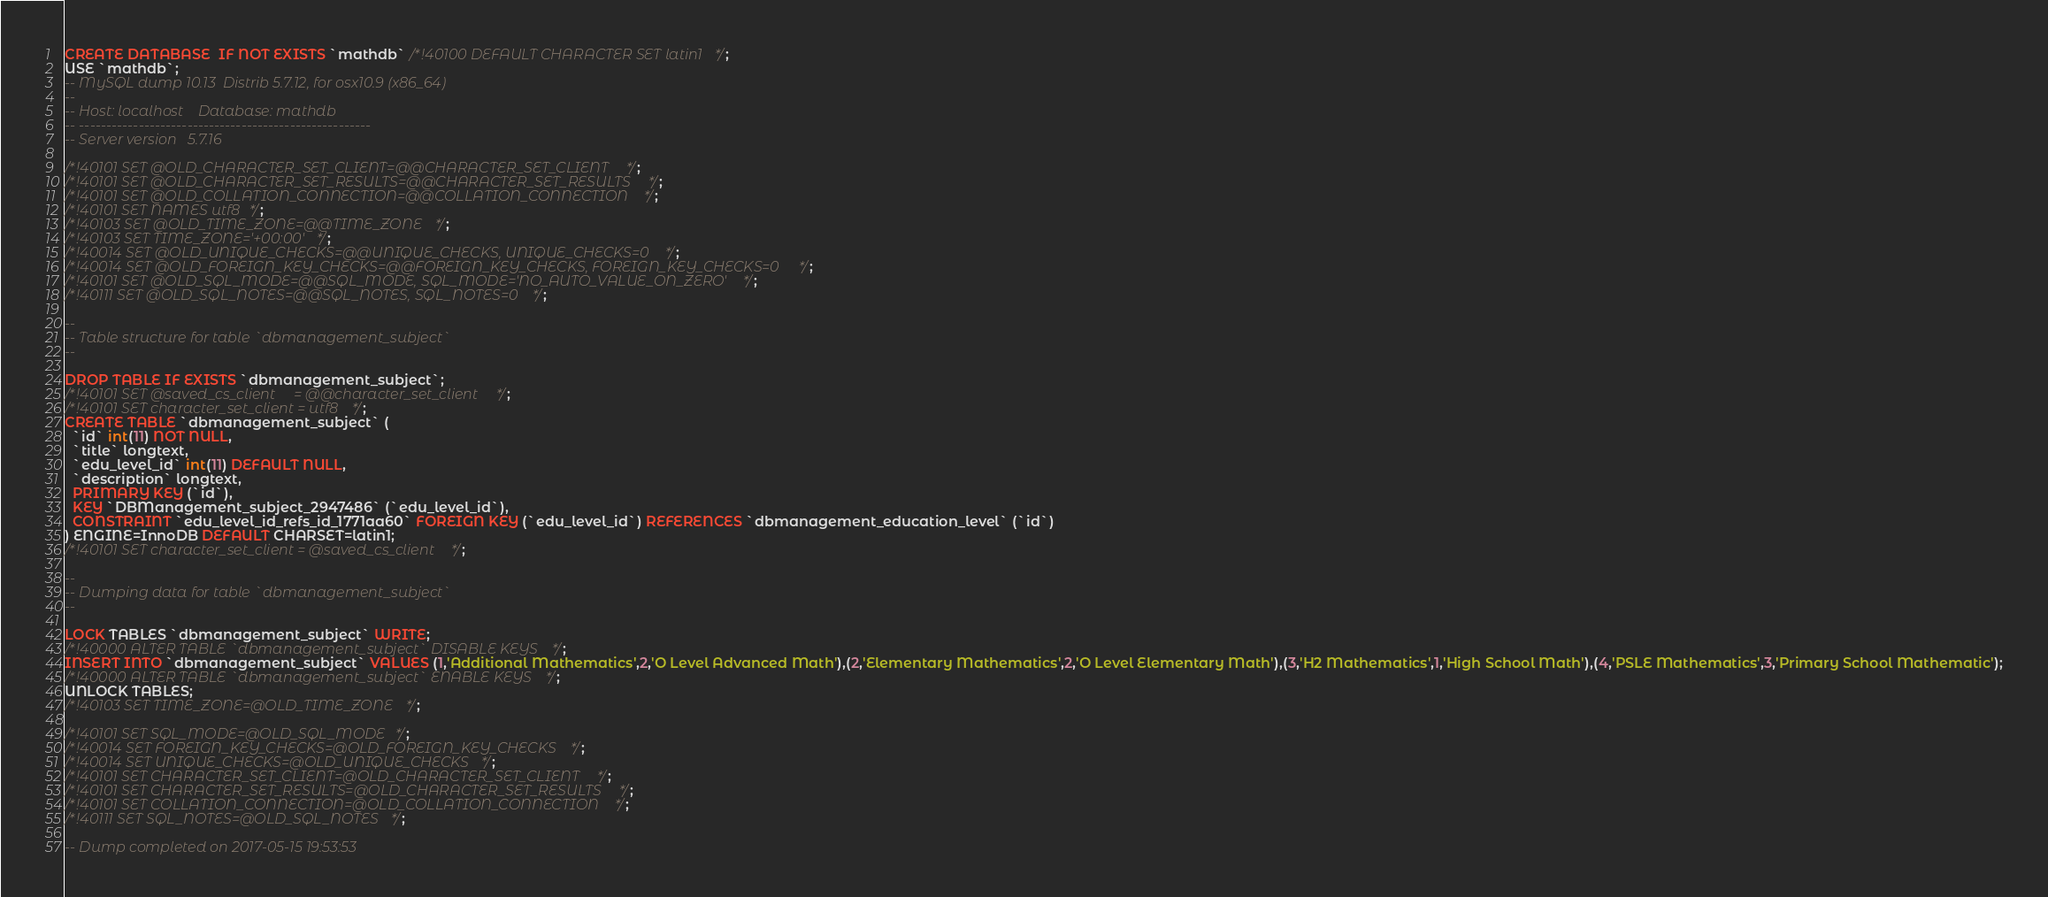Convert code to text. <code><loc_0><loc_0><loc_500><loc_500><_SQL_>CREATE DATABASE  IF NOT EXISTS `mathdb` /*!40100 DEFAULT CHARACTER SET latin1 */;
USE `mathdb`;
-- MySQL dump 10.13  Distrib 5.7.12, for osx10.9 (x86_64)
--
-- Host: localhost    Database: mathdb
-- ------------------------------------------------------
-- Server version	5.7.16

/*!40101 SET @OLD_CHARACTER_SET_CLIENT=@@CHARACTER_SET_CLIENT */;
/*!40101 SET @OLD_CHARACTER_SET_RESULTS=@@CHARACTER_SET_RESULTS */;
/*!40101 SET @OLD_COLLATION_CONNECTION=@@COLLATION_CONNECTION */;
/*!40101 SET NAMES utf8 */;
/*!40103 SET @OLD_TIME_ZONE=@@TIME_ZONE */;
/*!40103 SET TIME_ZONE='+00:00' */;
/*!40014 SET @OLD_UNIQUE_CHECKS=@@UNIQUE_CHECKS, UNIQUE_CHECKS=0 */;
/*!40014 SET @OLD_FOREIGN_KEY_CHECKS=@@FOREIGN_KEY_CHECKS, FOREIGN_KEY_CHECKS=0 */;
/*!40101 SET @OLD_SQL_MODE=@@SQL_MODE, SQL_MODE='NO_AUTO_VALUE_ON_ZERO' */;
/*!40111 SET @OLD_SQL_NOTES=@@SQL_NOTES, SQL_NOTES=0 */;

--
-- Table structure for table `dbmanagement_subject`
--

DROP TABLE IF EXISTS `dbmanagement_subject`;
/*!40101 SET @saved_cs_client     = @@character_set_client */;
/*!40101 SET character_set_client = utf8 */;
CREATE TABLE `dbmanagement_subject` (
  `id` int(11) NOT NULL,
  `title` longtext,
  `edu_level_id` int(11) DEFAULT NULL,
  `description` longtext,
  PRIMARY KEY (`id`),
  KEY `DBManagement_subject_2947486` (`edu_level_id`),
  CONSTRAINT `edu_level_id_refs_id_1771aa60` FOREIGN KEY (`edu_level_id`) REFERENCES `dbmanagement_education_level` (`id`)
) ENGINE=InnoDB DEFAULT CHARSET=latin1;
/*!40101 SET character_set_client = @saved_cs_client */;

--
-- Dumping data for table `dbmanagement_subject`
--

LOCK TABLES `dbmanagement_subject` WRITE;
/*!40000 ALTER TABLE `dbmanagement_subject` DISABLE KEYS */;
INSERT INTO `dbmanagement_subject` VALUES (1,'Additional Mathematics',2,'O Level Advanced Math'),(2,'Elementary Mathematics',2,'O Level Elementary Math'),(3,'H2 Mathematics',1,'High School Math'),(4,'PSLE Mathematics',3,'Primary School Mathematic');
/*!40000 ALTER TABLE `dbmanagement_subject` ENABLE KEYS */;
UNLOCK TABLES;
/*!40103 SET TIME_ZONE=@OLD_TIME_ZONE */;

/*!40101 SET SQL_MODE=@OLD_SQL_MODE */;
/*!40014 SET FOREIGN_KEY_CHECKS=@OLD_FOREIGN_KEY_CHECKS */;
/*!40014 SET UNIQUE_CHECKS=@OLD_UNIQUE_CHECKS */;
/*!40101 SET CHARACTER_SET_CLIENT=@OLD_CHARACTER_SET_CLIENT */;
/*!40101 SET CHARACTER_SET_RESULTS=@OLD_CHARACTER_SET_RESULTS */;
/*!40101 SET COLLATION_CONNECTION=@OLD_COLLATION_CONNECTION */;
/*!40111 SET SQL_NOTES=@OLD_SQL_NOTES */;

-- Dump completed on 2017-05-15 19:53:53
</code> 